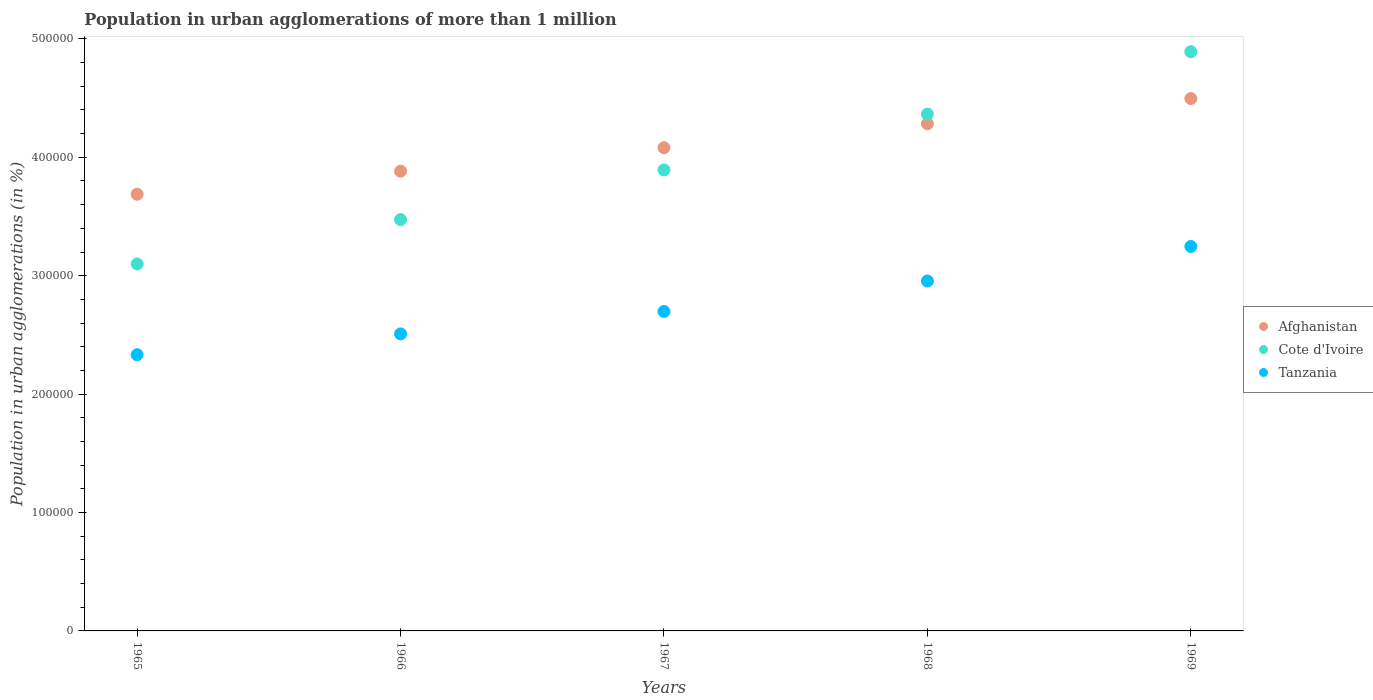How many different coloured dotlines are there?
Ensure brevity in your answer.  3. Is the number of dotlines equal to the number of legend labels?
Make the answer very short. Yes. What is the population in urban agglomerations in Cote d'Ivoire in 1966?
Your answer should be compact. 3.47e+05. Across all years, what is the maximum population in urban agglomerations in Tanzania?
Keep it short and to the point. 3.25e+05. Across all years, what is the minimum population in urban agglomerations in Tanzania?
Give a very brief answer. 2.33e+05. In which year was the population in urban agglomerations in Afghanistan maximum?
Provide a succinct answer. 1969. In which year was the population in urban agglomerations in Afghanistan minimum?
Make the answer very short. 1965. What is the total population in urban agglomerations in Tanzania in the graph?
Your response must be concise. 1.37e+06. What is the difference between the population in urban agglomerations in Afghanistan in 1966 and that in 1968?
Your answer should be very brief. -4.01e+04. What is the difference between the population in urban agglomerations in Cote d'Ivoire in 1966 and the population in urban agglomerations in Tanzania in 1968?
Your answer should be very brief. 5.19e+04. What is the average population in urban agglomerations in Afghanistan per year?
Provide a succinct answer. 4.09e+05. In the year 1966, what is the difference between the population in urban agglomerations in Afghanistan and population in urban agglomerations in Cote d'Ivoire?
Provide a short and direct response. 4.09e+04. What is the ratio of the population in urban agglomerations in Cote d'Ivoire in 1968 to that in 1969?
Offer a very short reply. 0.89. Is the population in urban agglomerations in Tanzania in 1966 less than that in 1968?
Offer a very short reply. Yes. What is the difference between the highest and the second highest population in urban agglomerations in Cote d'Ivoire?
Your answer should be very brief. 5.27e+04. What is the difference between the highest and the lowest population in urban agglomerations in Afghanistan?
Provide a succinct answer. 8.08e+04. Is it the case that in every year, the sum of the population in urban agglomerations in Cote d'Ivoire and population in urban agglomerations in Tanzania  is greater than the population in urban agglomerations in Afghanistan?
Ensure brevity in your answer.  Yes. Does the population in urban agglomerations in Afghanistan monotonically increase over the years?
Keep it short and to the point. Yes. How many dotlines are there?
Your response must be concise. 3. What is the difference between two consecutive major ticks on the Y-axis?
Your answer should be very brief. 1.00e+05. Does the graph contain grids?
Give a very brief answer. No. How many legend labels are there?
Ensure brevity in your answer.  3. How are the legend labels stacked?
Make the answer very short. Vertical. What is the title of the graph?
Offer a terse response. Population in urban agglomerations of more than 1 million. Does "Myanmar" appear as one of the legend labels in the graph?
Keep it short and to the point. No. What is the label or title of the X-axis?
Your response must be concise. Years. What is the label or title of the Y-axis?
Ensure brevity in your answer.  Population in urban agglomerations (in %). What is the Population in urban agglomerations (in %) in Afghanistan in 1965?
Your answer should be compact. 3.69e+05. What is the Population in urban agglomerations (in %) in Cote d'Ivoire in 1965?
Make the answer very short. 3.10e+05. What is the Population in urban agglomerations (in %) in Tanzania in 1965?
Your answer should be compact. 2.33e+05. What is the Population in urban agglomerations (in %) of Afghanistan in 1966?
Provide a short and direct response. 3.88e+05. What is the Population in urban agglomerations (in %) of Cote d'Ivoire in 1966?
Keep it short and to the point. 3.47e+05. What is the Population in urban agglomerations (in %) of Tanzania in 1966?
Your answer should be very brief. 2.51e+05. What is the Population in urban agglomerations (in %) of Afghanistan in 1967?
Offer a terse response. 4.08e+05. What is the Population in urban agglomerations (in %) of Cote d'Ivoire in 1967?
Provide a short and direct response. 3.89e+05. What is the Population in urban agglomerations (in %) of Tanzania in 1967?
Offer a very short reply. 2.70e+05. What is the Population in urban agglomerations (in %) of Afghanistan in 1968?
Offer a very short reply. 4.28e+05. What is the Population in urban agglomerations (in %) of Cote d'Ivoire in 1968?
Give a very brief answer. 4.36e+05. What is the Population in urban agglomerations (in %) of Tanzania in 1968?
Offer a very short reply. 2.96e+05. What is the Population in urban agglomerations (in %) in Afghanistan in 1969?
Offer a very short reply. 4.50e+05. What is the Population in urban agglomerations (in %) in Cote d'Ivoire in 1969?
Your response must be concise. 4.89e+05. What is the Population in urban agglomerations (in %) of Tanzania in 1969?
Your answer should be compact. 3.25e+05. Across all years, what is the maximum Population in urban agglomerations (in %) of Afghanistan?
Ensure brevity in your answer.  4.50e+05. Across all years, what is the maximum Population in urban agglomerations (in %) in Cote d'Ivoire?
Keep it short and to the point. 4.89e+05. Across all years, what is the maximum Population in urban agglomerations (in %) in Tanzania?
Make the answer very short. 3.25e+05. Across all years, what is the minimum Population in urban agglomerations (in %) in Afghanistan?
Make the answer very short. 3.69e+05. Across all years, what is the minimum Population in urban agglomerations (in %) of Cote d'Ivoire?
Provide a short and direct response. 3.10e+05. Across all years, what is the minimum Population in urban agglomerations (in %) of Tanzania?
Your answer should be compact. 2.33e+05. What is the total Population in urban agglomerations (in %) in Afghanistan in the graph?
Offer a very short reply. 2.04e+06. What is the total Population in urban agglomerations (in %) of Cote d'Ivoire in the graph?
Provide a short and direct response. 1.97e+06. What is the total Population in urban agglomerations (in %) in Tanzania in the graph?
Ensure brevity in your answer.  1.37e+06. What is the difference between the Population in urban agglomerations (in %) of Afghanistan in 1965 and that in 1966?
Keep it short and to the point. -1.94e+04. What is the difference between the Population in urban agglomerations (in %) of Cote d'Ivoire in 1965 and that in 1966?
Give a very brief answer. -3.75e+04. What is the difference between the Population in urban agglomerations (in %) of Tanzania in 1965 and that in 1966?
Give a very brief answer. -1.76e+04. What is the difference between the Population in urban agglomerations (in %) of Afghanistan in 1965 and that in 1967?
Your answer should be compact. -3.93e+04. What is the difference between the Population in urban agglomerations (in %) in Cote d'Ivoire in 1965 and that in 1967?
Give a very brief answer. -7.94e+04. What is the difference between the Population in urban agglomerations (in %) in Tanzania in 1965 and that in 1967?
Offer a very short reply. -3.65e+04. What is the difference between the Population in urban agglomerations (in %) of Afghanistan in 1965 and that in 1968?
Offer a terse response. -5.96e+04. What is the difference between the Population in urban agglomerations (in %) of Cote d'Ivoire in 1965 and that in 1968?
Provide a succinct answer. -1.27e+05. What is the difference between the Population in urban agglomerations (in %) in Tanzania in 1965 and that in 1968?
Provide a short and direct response. -6.23e+04. What is the difference between the Population in urban agglomerations (in %) of Afghanistan in 1965 and that in 1969?
Offer a terse response. -8.08e+04. What is the difference between the Population in urban agglomerations (in %) of Cote d'Ivoire in 1965 and that in 1969?
Your answer should be compact. -1.79e+05. What is the difference between the Population in urban agglomerations (in %) in Tanzania in 1965 and that in 1969?
Keep it short and to the point. -9.14e+04. What is the difference between the Population in urban agglomerations (in %) of Afghanistan in 1966 and that in 1967?
Keep it short and to the point. -1.99e+04. What is the difference between the Population in urban agglomerations (in %) of Cote d'Ivoire in 1966 and that in 1967?
Your answer should be very brief. -4.20e+04. What is the difference between the Population in urban agglomerations (in %) in Tanzania in 1966 and that in 1967?
Offer a very short reply. -1.89e+04. What is the difference between the Population in urban agglomerations (in %) of Afghanistan in 1966 and that in 1968?
Your answer should be compact. -4.01e+04. What is the difference between the Population in urban agglomerations (in %) of Cote d'Ivoire in 1966 and that in 1968?
Make the answer very short. -8.91e+04. What is the difference between the Population in urban agglomerations (in %) of Tanzania in 1966 and that in 1968?
Provide a short and direct response. -4.47e+04. What is the difference between the Population in urban agglomerations (in %) of Afghanistan in 1966 and that in 1969?
Provide a short and direct response. -6.14e+04. What is the difference between the Population in urban agglomerations (in %) in Cote d'Ivoire in 1966 and that in 1969?
Provide a short and direct response. -1.42e+05. What is the difference between the Population in urban agglomerations (in %) in Tanzania in 1966 and that in 1969?
Your response must be concise. -7.38e+04. What is the difference between the Population in urban agglomerations (in %) in Afghanistan in 1967 and that in 1968?
Offer a very short reply. -2.03e+04. What is the difference between the Population in urban agglomerations (in %) in Cote d'Ivoire in 1967 and that in 1968?
Offer a very short reply. -4.71e+04. What is the difference between the Population in urban agglomerations (in %) in Tanzania in 1967 and that in 1968?
Offer a terse response. -2.57e+04. What is the difference between the Population in urban agglomerations (in %) of Afghanistan in 1967 and that in 1969?
Give a very brief answer. -4.15e+04. What is the difference between the Population in urban agglomerations (in %) in Cote d'Ivoire in 1967 and that in 1969?
Offer a very short reply. -9.98e+04. What is the difference between the Population in urban agglomerations (in %) in Tanzania in 1967 and that in 1969?
Give a very brief answer. -5.49e+04. What is the difference between the Population in urban agglomerations (in %) in Afghanistan in 1968 and that in 1969?
Offer a very short reply. -2.12e+04. What is the difference between the Population in urban agglomerations (in %) in Cote d'Ivoire in 1968 and that in 1969?
Make the answer very short. -5.27e+04. What is the difference between the Population in urban agglomerations (in %) of Tanzania in 1968 and that in 1969?
Offer a terse response. -2.92e+04. What is the difference between the Population in urban agglomerations (in %) of Afghanistan in 1965 and the Population in urban agglomerations (in %) of Cote d'Ivoire in 1966?
Keep it short and to the point. 2.14e+04. What is the difference between the Population in urban agglomerations (in %) in Afghanistan in 1965 and the Population in urban agglomerations (in %) in Tanzania in 1966?
Ensure brevity in your answer.  1.18e+05. What is the difference between the Population in urban agglomerations (in %) of Cote d'Ivoire in 1965 and the Population in urban agglomerations (in %) of Tanzania in 1966?
Give a very brief answer. 5.91e+04. What is the difference between the Population in urban agglomerations (in %) in Afghanistan in 1965 and the Population in urban agglomerations (in %) in Cote d'Ivoire in 1967?
Your response must be concise. -2.05e+04. What is the difference between the Population in urban agglomerations (in %) in Afghanistan in 1965 and the Population in urban agglomerations (in %) in Tanzania in 1967?
Provide a short and direct response. 9.90e+04. What is the difference between the Population in urban agglomerations (in %) of Cote d'Ivoire in 1965 and the Population in urban agglomerations (in %) of Tanzania in 1967?
Keep it short and to the point. 4.01e+04. What is the difference between the Population in urban agglomerations (in %) of Afghanistan in 1965 and the Population in urban agglomerations (in %) of Cote d'Ivoire in 1968?
Keep it short and to the point. -6.77e+04. What is the difference between the Population in urban agglomerations (in %) of Afghanistan in 1965 and the Population in urban agglomerations (in %) of Tanzania in 1968?
Give a very brief answer. 7.33e+04. What is the difference between the Population in urban agglomerations (in %) in Cote d'Ivoire in 1965 and the Population in urban agglomerations (in %) in Tanzania in 1968?
Keep it short and to the point. 1.44e+04. What is the difference between the Population in urban agglomerations (in %) of Afghanistan in 1965 and the Population in urban agglomerations (in %) of Cote d'Ivoire in 1969?
Make the answer very short. -1.20e+05. What is the difference between the Population in urban agglomerations (in %) in Afghanistan in 1965 and the Population in urban agglomerations (in %) in Tanzania in 1969?
Your answer should be compact. 4.41e+04. What is the difference between the Population in urban agglomerations (in %) of Cote d'Ivoire in 1965 and the Population in urban agglomerations (in %) of Tanzania in 1969?
Provide a short and direct response. -1.48e+04. What is the difference between the Population in urban agglomerations (in %) in Afghanistan in 1966 and the Population in urban agglomerations (in %) in Cote d'Ivoire in 1967?
Provide a short and direct response. -1122. What is the difference between the Population in urban agglomerations (in %) of Afghanistan in 1966 and the Population in urban agglomerations (in %) of Tanzania in 1967?
Your response must be concise. 1.18e+05. What is the difference between the Population in urban agglomerations (in %) of Cote d'Ivoire in 1966 and the Population in urban agglomerations (in %) of Tanzania in 1967?
Give a very brief answer. 7.76e+04. What is the difference between the Population in urban agglomerations (in %) of Afghanistan in 1966 and the Population in urban agglomerations (in %) of Cote d'Ivoire in 1968?
Your answer should be very brief. -4.82e+04. What is the difference between the Population in urban agglomerations (in %) of Afghanistan in 1966 and the Population in urban agglomerations (in %) of Tanzania in 1968?
Keep it short and to the point. 9.27e+04. What is the difference between the Population in urban agglomerations (in %) of Cote d'Ivoire in 1966 and the Population in urban agglomerations (in %) of Tanzania in 1968?
Provide a succinct answer. 5.19e+04. What is the difference between the Population in urban agglomerations (in %) in Afghanistan in 1966 and the Population in urban agglomerations (in %) in Cote d'Ivoire in 1969?
Offer a very short reply. -1.01e+05. What is the difference between the Population in urban agglomerations (in %) in Afghanistan in 1966 and the Population in urban agglomerations (in %) in Tanzania in 1969?
Offer a very short reply. 6.35e+04. What is the difference between the Population in urban agglomerations (in %) of Cote d'Ivoire in 1966 and the Population in urban agglomerations (in %) of Tanzania in 1969?
Offer a terse response. 2.27e+04. What is the difference between the Population in urban agglomerations (in %) of Afghanistan in 1967 and the Population in urban agglomerations (in %) of Cote d'Ivoire in 1968?
Your response must be concise. -2.84e+04. What is the difference between the Population in urban agglomerations (in %) of Afghanistan in 1967 and the Population in urban agglomerations (in %) of Tanzania in 1968?
Your answer should be very brief. 1.13e+05. What is the difference between the Population in urban agglomerations (in %) in Cote d'Ivoire in 1967 and the Population in urban agglomerations (in %) in Tanzania in 1968?
Give a very brief answer. 9.38e+04. What is the difference between the Population in urban agglomerations (in %) in Afghanistan in 1967 and the Population in urban agglomerations (in %) in Cote d'Ivoire in 1969?
Provide a succinct answer. -8.11e+04. What is the difference between the Population in urban agglomerations (in %) in Afghanistan in 1967 and the Population in urban agglomerations (in %) in Tanzania in 1969?
Make the answer very short. 8.34e+04. What is the difference between the Population in urban agglomerations (in %) of Cote d'Ivoire in 1967 and the Population in urban agglomerations (in %) of Tanzania in 1969?
Ensure brevity in your answer.  6.47e+04. What is the difference between the Population in urban agglomerations (in %) of Afghanistan in 1968 and the Population in urban agglomerations (in %) of Cote d'Ivoire in 1969?
Offer a very short reply. -6.08e+04. What is the difference between the Population in urban agglomerations (in %) in Afghanistan in 1968 and the Population in urban agglomerations (in %) in Tanzania in 1969?
Provide a short and direct response. 1.04e+05. What is the difference between the Population in urban agglomerations (in %) of Cote d'Ivoire in 1968 and the Population in urban agglomerations (in %) of Tanzania in 1969?
Provide a short and direct response. 1.12e+05. What is the average Population in urban agglomerations (in %) of Afghanistan per year?
Your answer should be compact. 4.09e+05. What is the average Population in urban agglomerations (in %) in Cote d'Ivoire per year?
Your response must be concise. 3.94e+05. What is the average Population in urban agglomerations (in %) of Tanzania per year?
Your response must be concise. 2.75e+05. In the year 1965, what is the difference between the Population in urban agglomerations (in %) of Afghanistan and Population in urban agglomerations (in %) of Cote d'Ivoire?
Give a very brief answer. 5.89e+04. In the year 1965, what is the difference between the Population in urban agglomerations (in %) of Afghanistan and Population in urban agglomerations (in %) of Tanzania?
Offer a terse response. 1.36e+05. In the year 1965, what is the difference between the Population in urban agglomerations (in %) in Cote d'Ivoire and Population in urban agglomerations (in %) in Tanzania?
Give a very brief answer. 7.67e+04. In the year 1966, what is the difference between the Population in urban agglomerations (in %) in Afghanistan and Population in urban agglomerations (in %) in Cote d'Ivoire?
Offer a very short reply. 4.09e+04. In the year 1966, what is the difference between the Population in urban agglomerations (in %) of Afghanistan and Population in urban agglomerations (in %) of Tanzania?
Your answer should be very brief. 1.37e+05. In the year 1966, what is the difference between the Population in urban agglomerations (in %) of Cote d'Ivoire and Population in urban agglomerations (in %) of Tanzania?
Your answer should be compact. 9.65e+04. In the year 1967, what is the difference between the Population in urban agglomerations (in %) in Afghanistan and Population in urban agglomerations (in %) in Cote d'Ivoire?
Your answer should be very brief. 1.87e+04. In the year 1967, what is the difference between the Population in urban agglomerations (in %) in Afghanistan and Population in urban agglomerations (in %) in Tanzania?
Ensure brevity in your answer.  1.38e+05. In the year 1967, what is the difference between the Population in urban agglomerations (in %) of Cote d'Ivoire and Population in urban agglomerations (in %) of Tanzania?
Your answer should be compact. 1.20e+05. In the year 1968, what is the difference between the Population in urban agglomerations (in %) in Afghanistan and Population in urban agglomerations (in %) in Cote d'Ivoire?
Your answer should be compact. -8109. In the year 1968, what is the difference between the Population in urban agglomerations (in %) of Afghanistan and Population in urban agglomerations (in %) of Tanzania?
Your response must be concise. 1.33e+05. In the year 1968, what is the difference between the Population in urban agglomerations (in %) of Cote d'Ivoire and Population in urban agglomerations (in %) of Tanzania?
Ensure brevity in your answer.  1.41e+05. In the year 1969, what is the difference between the Population in urban agglomerations (in %) of Afghanistan and Population in urban agglomerations (in %) of Cote d'Ivoire?
Your response must be concise. -3.96e+04. In the year 1969, what is the difference between the Population in urban agglomerations (in %) of Afghanistan and Population in urban agglomerations (in %) of Tanzania?
Offer a terse response. 1.25e+05. In the year 1969, what is the difference between the Population in urban agglomerations (in %) of Cote d'Ivoire and Population in urban agglomerations (in %) of Tanzania?
Provide a short and direct response. 1.64e+05. What is the ratio of the Population in urban agglomerations (in %) of Afghanistan in 1965 to that in 1966?
Your response must be concise. 0.95. What is the ratio of the Population in urban agglomerations (in %) in Cote d'Ivoire in 1965 to that in 1966?
Your answer should be very brief. 0.89. What is the ratio of the Population in urban agglomerations (in %) in Tanzania in 1965 to that in 1966?
Ensure brevity in your answer.  0.93. What is the ratio of the Population in urban agglomerations (in %) of Afghanistan in 1965 to that in 1967?
Provide a succinct answer. 0.9. What is the ratio of the Population in urban agglomerations (in %) in Cote d'Ivoire in 1965 to that in 1967?
Your answer should be very brief. 0.8. What is the ratio of the Population in urban agglomerations (in %) of Tanzania in 1965 to that in 1967?
Your answer should be compact. 0.86. What is the ratio of the Population in urban agglomerations (in %) of Afghanistan in 1965 to that in 1968?
Ensure brevity in your answer.  0.86. What is the ratio of the Population in urban agglomerations (in %) of Cote d'Ivoire in 1965 to that in 1968?
Keep it short and to the point. 0.71. What is the ratio of the Population in urban agglomerations (in %) of Tanzania in 1965 to that in 1968?
Your answer should be compact. 0.79. What is the ratio of the Population in urban agglomerations (in %) in Afghanistan in 1965 to that in 1969?
Offer a very short reply. 0.82. What is the ratio of the Population in urban agglomerations (in %) in Cote d'Ivoire in 1965 to that in 1969?
Offer a very short reply. 0.63. What is the ratio of the Population in urban agglomerations (in %) of Tanzania in 1965 to that in 1969?
Ensure brevity in your answer.  0.72. What is the ratio of the Population in urban agglomerations (in %) in Afghanistan in 1966 to that in 1967?
Ensure brevity in your answer.  0.95. What is the ratio of the Population in urban agglomerations (in %) in Cote d'Ivoire in 1966 to that in 1967?
Provide a short and direct response. 0.89. What is the ratio of the Population in urban agglomerations (in %) in Tanzania in 1966 to that in 1967?
Your response must be concise. 0.93. What is the ratio of the Population in urban agglomerations (in %) in Afghanistan in 1966 to that in 1968?
Make the answer very short. 0.91. What is the ratio of the Population in urban agglomerations (in %) of Cote d'Ivoire in 1966 to that in 1968?
Make the answer very short. 0.8. What is the ratio of the Population in urban agglomerations (in %) in Tanzania in 1966 to that in 1968?
Provide a succinct answer. 0.85. What is the ratio of the Population in urban agglomerations (in %) in Afghanistan in 1966 to that in 1969?
Your response must be concise. 0.86. What is the ratio of the Population in urban agglomerations (in %) in Cote d'Ivoire in 1966 to that in 1969?
Ensure brevity in your answer.  0.71. What is the ratio of the Population in urban agglomerations (in %) of Tanzania in 1966 to that in 1969?
Make the answer very short. 0.77. What is the ratio of the Population in urban agglomerations (in %) in Afghanistan in 1967 to that in 1968?
Your response must be concise. 0.95. What is the ratio of the Population in urban agglomerations (in %) in Cote d'Ivoire in 1967 to that in 1968?
Offer a very short reply. 0.89. What is the ratio of the Population in urban agglomerations (in %) in Tanzania in 1967 to that in 1968?
Provide a short and direct response. 0.91. What is the ratio of the Population in urban agglomerations (in %) of Afghanistan in 1967 to that in 1969?
Your response must be concise. 0.91. What is the ratio of the Population in urban agglomerations (in %) of Cote d'Ivoire in 1967 to that in 1969?
Keep it short and to the point. 0.8. What is the ratio of the Population in urban agglomerations (in %) in Tanzania in 1967 to that in 1969?
Your response must be concise. 0.83. What is the ratio of the Population in urban agglomerations (in %) in Afghanistan in 1968 to that in 1969?
Provide a succinct answer. 0.95. What is the ratio of the Population in urban agglomerations (in %) of Cote d'Ivoire in 1968 to that in 1969?
Your answer should be very brief. 0.89. What is the ratio of the Population in urban agglomerations (in %) of Tanzania in 1968 to that in 1969?
Provide a succinct answer. 0.91. What is the difference between the highest and the second highest Population in urban agglomerations (in %) of Afghanistan?
Offer a very short reply. 2.12e+04. What is the difference between the highest and the second highest Population in urban agglomerations (in %) of Cote d'Ivoire?
Ensure brevity in your answer.  5.27e+04. What is the difference between the highest and the second highest Population in urban agglomerations (in %) of Tanzania?
Offer a terse response. 2.92e+04. What is the difference between the highest and the lowest Population in urban agglomerations (in %) in Afghanistan?
Keep it short and to the point. 8.08e+04. What is the difference between the highest and the lowest Population in urban agglomerations (in %) in Cote d'Ivoire?
Your answer should be very brief. 1.79e+05. What is the difference between the highest and the lowest Population in urban agglomerations (in %) in Tanzania?
Give a very brief answer. 9.14e+04. 